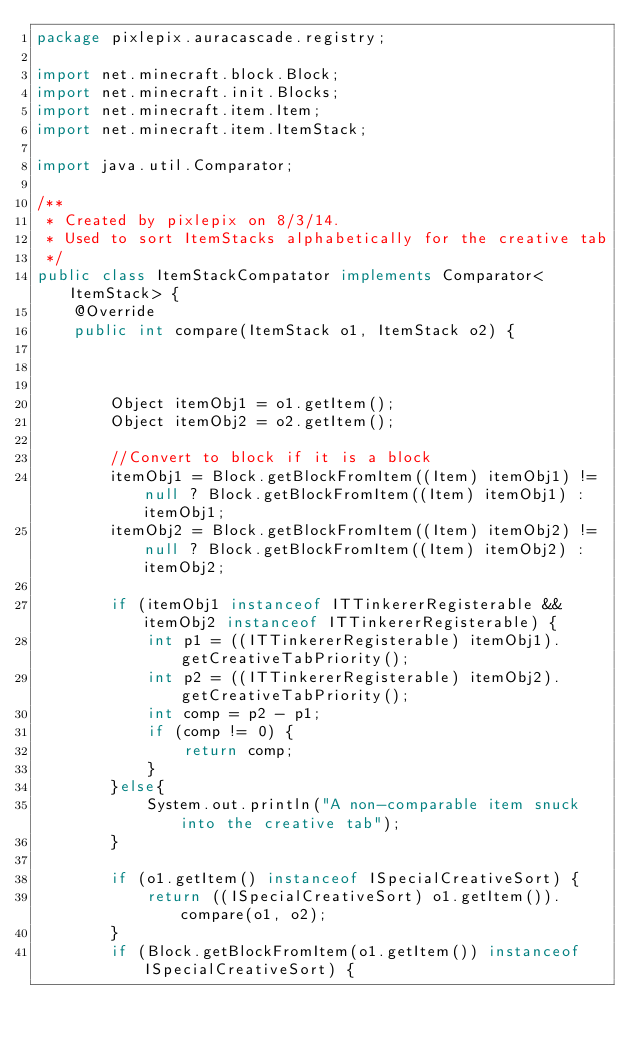<code> <loc_0><loc_0><loc_500><loc_500><_Java_>package pixlepix.auracascade.registry;

import net.minecraft.block.Block;
import net.minecraft.init.Blocks;
import net.minecraft.item.Item;
import net.minecraft.item.ItemStack;

import java.util.Comparator;

/**
 * Created by pixlepix on 8/3/14.
 * Used to sort ItemStacks alphabetically for the creative tab
 */
public class ItemStackCompatator implements Comparator<ItemStack> {
    @Override
    public int compare(ItemStack o1, ItemStack o2) {



        Object itemObj1 = o1.getItem();
        Object itemObj2 = o2.getItem();

        //Convert to block if it is a block
        itemObj1 = Block.getBlockFromItem((Item) itemObj1) != null ? Block.getBlockFromItem((Item) itemObj1) : itemObj1;
        itemObj2 = Block.getBlockFromItem((Item) itemObj2) != null ? Block.getBlockFromItem((Item) itemObj2) : itemObj2;

        if (itemObj1 instanceof ITTinkererRegisterable && itemObj2 instanceof ITTinkererRegisterable) {
            int p1 = ((ITTinkererRegisterable) itemObj1).getCreativeTabPriority();
            int p2 = ((ITTinkererRegisterable) itemObj2).getCreativeTabPriority();
            int comp = p2 - p1;
            if (comp != 0) {
                return comp;
            }
        }else{
            System.out.println("A non-comparable item snuck into the creative tab");
        }

        if (o1.getItem() instanceof ISpecialCreativeSort) {
            return ((ISpecialCreativeSort) o1.getItem()).compare(o1, o2);
        }
        if (Block.getBlockFromItem(o1.getItem()) instanceof ISpecialCreativeSort) {</code> 